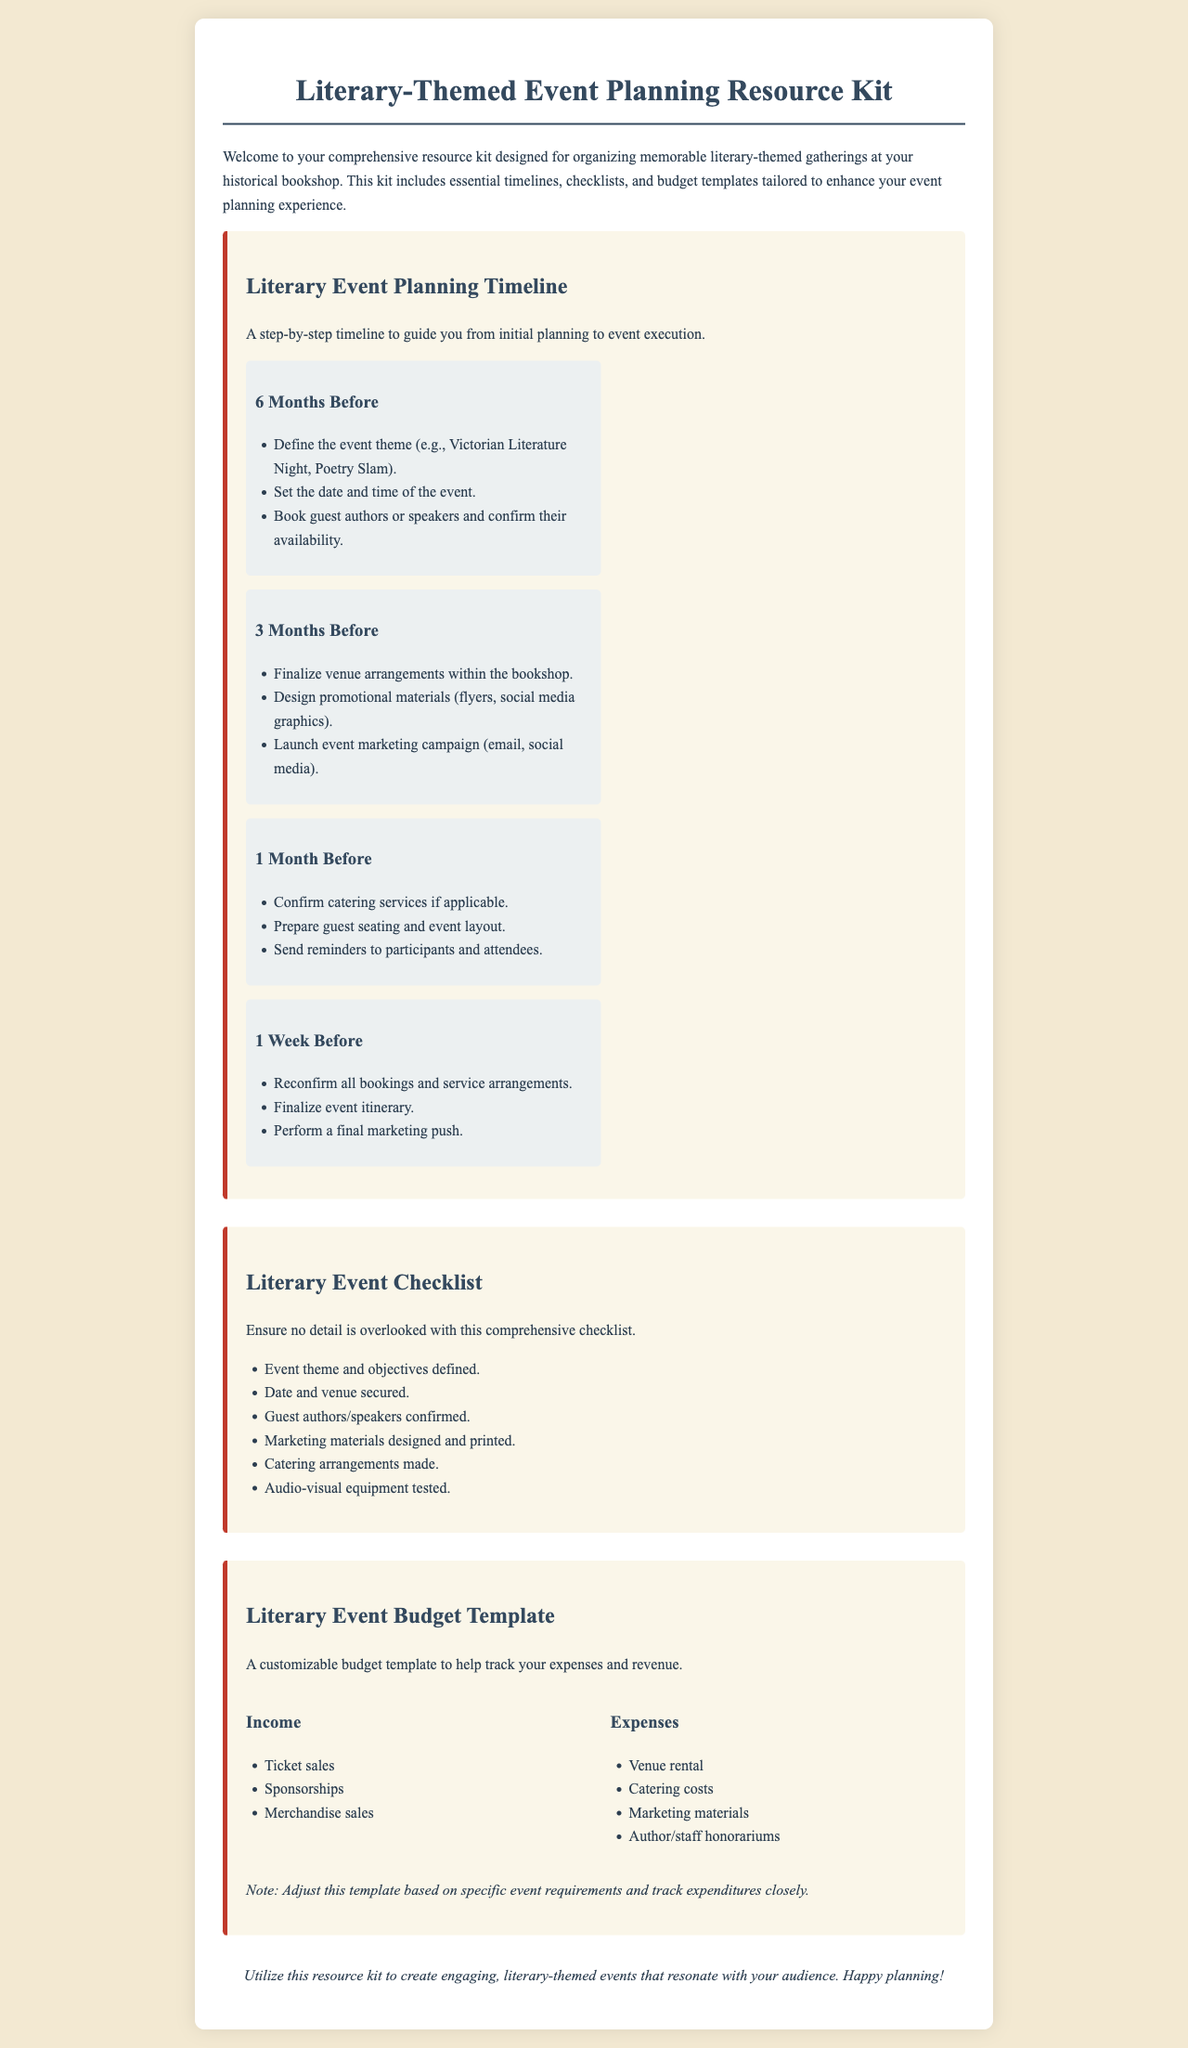What is the title of the document? The title is presented in the header of the document, clearly stating its purpose for the reader.
Answer: Literary-Themed Event Planning Resource Kit How many months before the event should guest authors be booked? According to the timeline in the document, guest authors should be booked six months prior to the event.
Answer: 6 Months What is one of the checklist items? The checklist includes various essential tasks, one of which needs to be confirmed for event planning.
Answer: Event theme and objectives defined What should be prepared one month before the event? The timeline outlines several preparations, one of which relates to guest accommodation and seating.
Answer: Prepare guest seating and event layout What are the two categories listed in the budget template? The budget template is divided into specific sections detailing the sources of income and expenditures to be tracked.
Answer: Income and Expenses What color is the background of the document? The background color is mentioned in the style section of the code, indicating the document's aesthetic appeal.
Answer: #f3e9d2 Which event marketing channel is mentioned for promotion? The marketing campaign strategies listed include a variety of outreach methods to enhance event visibility.
Answer: Social media How many weeks before the event should the final marketing push be performed? The timeline specifies the timing for this vital promotional activity during the event planning.
Answer: 1 Week What is the suggested catering arrangement timeframe? The timeline specifies when to finalize catering services, ensuring smooth event catering logistics.
Answer: 1 Month 